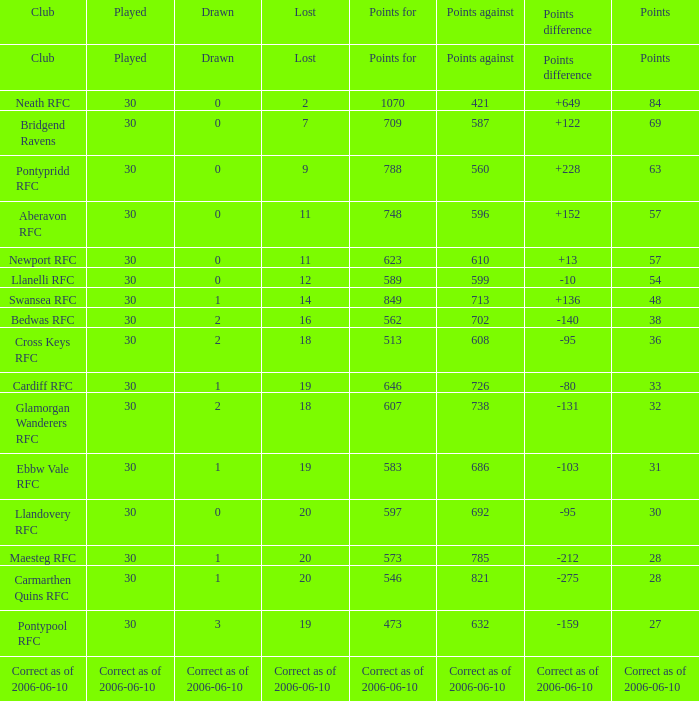What is vanished, when depicted is "2", and when coordinates is "36"? 18.0. 